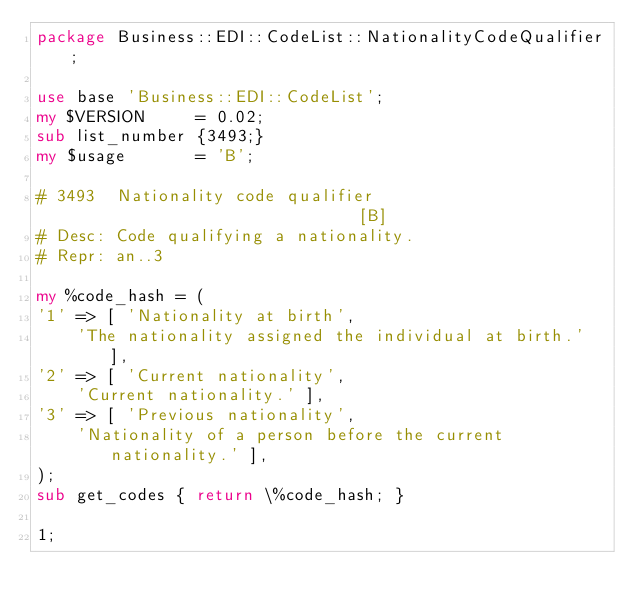<code> <loc_0><loc_0><loc_500><loc_500><_Perl_>package Business::EDI::CodeList::NationalityCodeQualifier;

use base 'Business::EDI::CodeList';
my $VERSION     = 0.02;
sub list_number {3493;}
my $usage       = 'B';

# 3493  Nationality code qualifier                              [B]
# Desc: Code qualifying a nationality.
# Repr: an..3

my %code_hash = (
'1' => [ 'Nationality at birth',
    'The nationality assigned the individual at birth.' ],
'2' => [ 'Current nationality',
    'Current nationality.' ],
'3' => [ 'Previous nationality',
    'Nationality of a person before the current nationality.' ],
);
sub get_codes { return \%code_hash; }

1;
</code> 